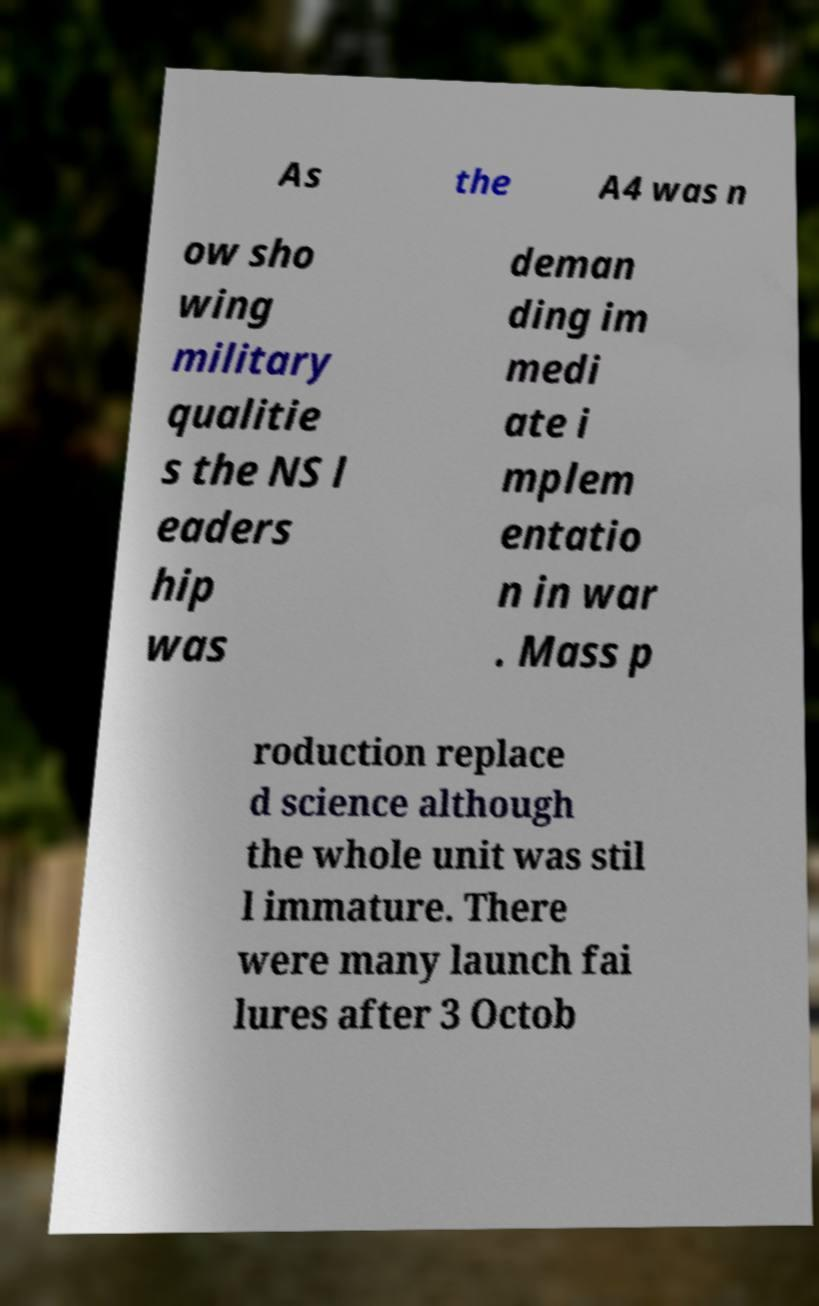I need the written content from this picture converted into text. Can you do that? As the A4 was n ow sho wing military qualitie s the NS l eaders hip was deman ding im medi ate i mplem entatio n in war . Mass p roduction replace d science although the whole unit was stil l immature. There were many launch fai lures after 3 Octob 